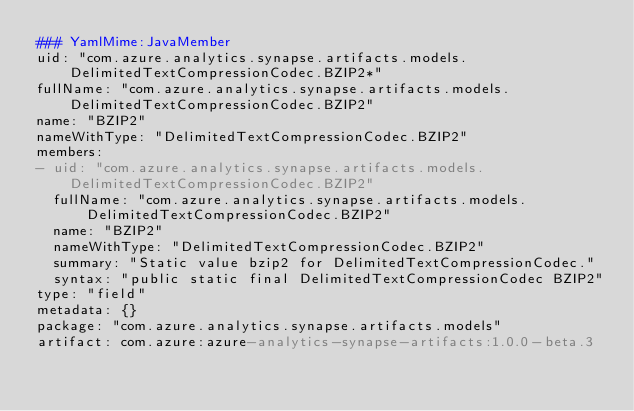<code> <loc_0><loc_0><loc_500><loc_500><_YAML_>### YamlMime:JavaMember
uid: "com.azure.analytics.synapse.artifacts.models.DelimitedTextCompressionCodec.BZIP2*"
fullName: "com.azure.analytics.synapse.artifacts.models.DelimitedTextCompressionCodec.BZIP2"
name: "BZIP2"
nameWithType: "DelimitedTextCompressionCodec.BZIP2"
members:
- uid: "com.azure.analytics.synapse.artifacts.models.DelimitedTextCompressionCodec.BZIP2"
  fullName: "com.azure.analytics.synapse.artifacts.models.DelimitedTextCompressionCodec.BZIP2"
  name: "BZIP2"
  nameWithType: "DelimitedTextCompressionCodec.BZIP2"
  summary: "Static value bzip2 for DelimitedTextCompressionCodec."
  syntax: "public static final DelimitedTextCompressionCodec BZIP2"
type: "field"
metadata: {}
package: "com.azure.analytics.synapse.artifacts.models"
artifact: com.azure:azure-analytics-synapse-artifacts:1.0.0-beta.3
</code> 